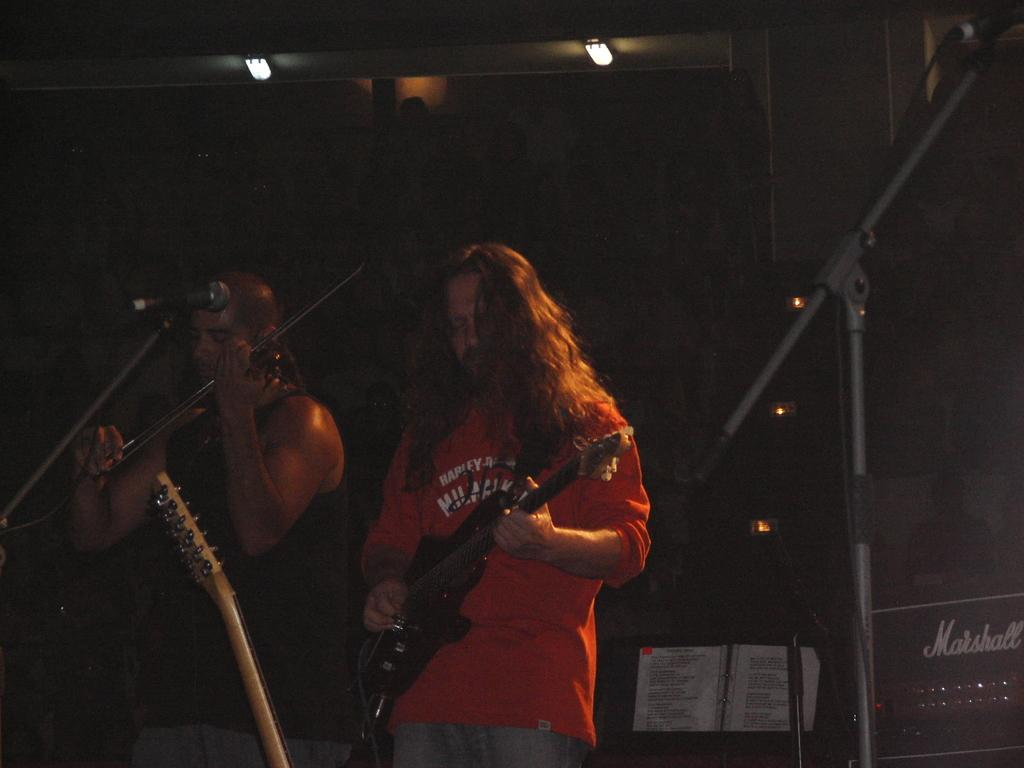How many people are in the image? There are two people standing in the image. What are the people wearing? The people are wearing clothes. What musical instrument can be seen in the image? There is a guitar in the image. What device is used for amplifying sound in the image? There is a microphone in the image. What other musical instruments are present in the image? There are other musical instruments in the image. What non-musical item can be seen in the image? There is a book in the image. What source of illumination is present in the image? There is a light in the image. What object is used for holding or displaying items in the image? There is a stand in the image. What type of street is visible in the image? There is no street visible in the image. What emotion is the lead person in the image displaying? The image does not show any emotions or expressions of the people, so it cannot be determined what emotion they might be feeling. 